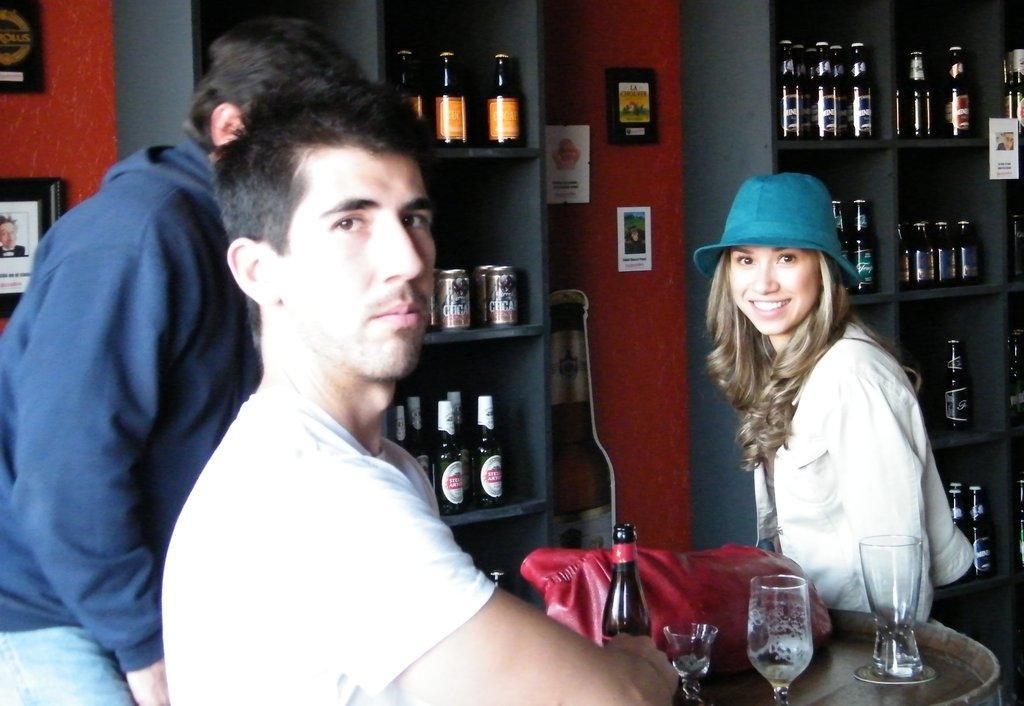Could you give a brief overview of what you see in this image? In this image, I can see three people. This looks like a table with a bottle, handbag and glasses on it. I can see the frames attached to the wall. This looks like a cutout of a bottle. I can see the tins and bottles arranged in the rack. 